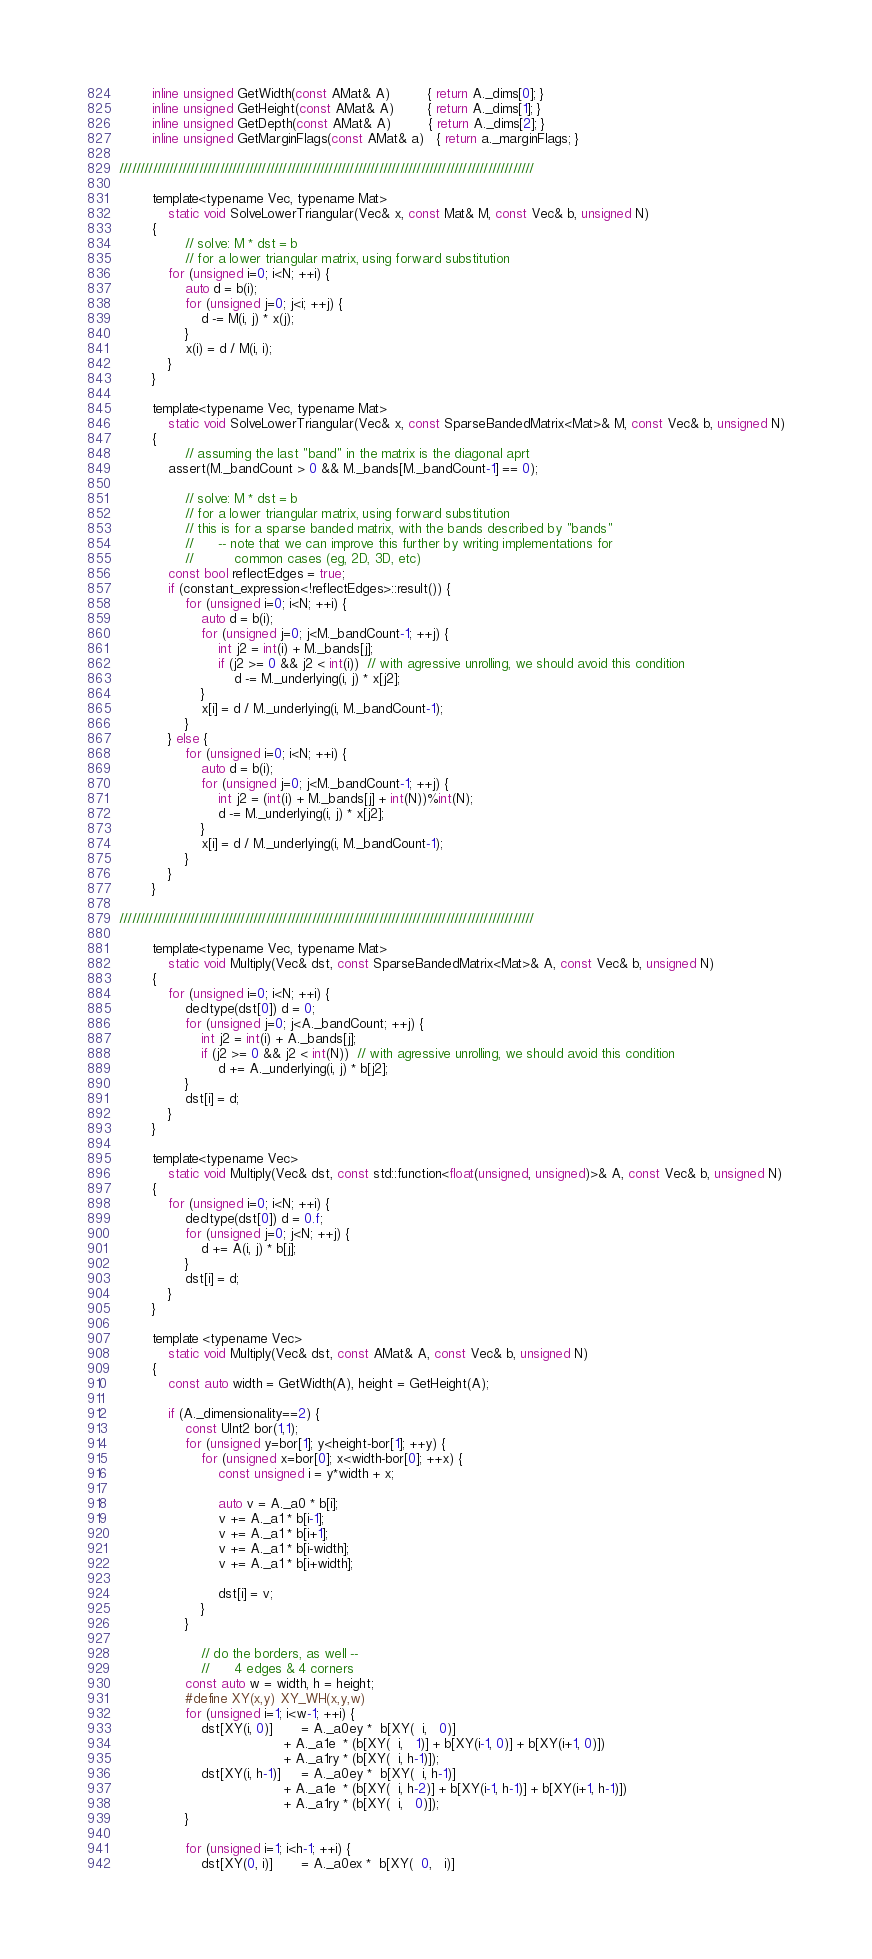<code> <loc_0><loc_0><loc_500><loc_500><_C_>        inline unsigned GetWidth(const AMat& A)         { return A._dims[0]; }
        inline unsigned GetHeight(const AMat& A)        { return A._dims[1]; }
        inline unsigned GetDepth(const AMat& A)         { return A._dims[2]; }
        inline unsigned GetMarginFlags(const AMat& a)   { return a._marginFlags; }

///////////////////////////////////////////////////////////////////////////////////////////////////

        template<typename Vec, typename Mat>
            static void SolveLowerTriangular(Vec& x, const Mat& M, const Vec& b, unsigned N)
        {
                // solve: M * dst = b
                // for a lower triangular matrix, using forward substitution
            for (unsigned i=0; i<N; ++i) {
                auto d = b(i);
                for (unsigned j=0; j<i; ++j) {
                    d -= M(i, j) * x(j);
                }
                x(i) = d / M(i, i);
            }
        }

        template<typename Vec, typename Mat>
            static void SolveLowerTriangular(Vec& x, const SparseBandedMatrix<Mat>& M, const Vec& b, unsigned N)
        {
                // assuming the last "band" in the matrix is the diagonal aprt
            assert(M._bandCount > 0 && M._bands[M._bandCount-1] == 0);

                // solve: M * dst = b
                // for a lower triangular matrix, using forward substitution
                // this is for a sparse banded matrix, with the bands described by "bands"
                //      -- note that we can improve this further by writing implementations for
                //          common cases (eg, 2D, 3D, etc)
            const bool reflectEdges = true;
            if (constant_expression<!reflectEdges>::result()) {
                for (unsigned i=0; i<N; ++i) {
                    auto d = b(i);
                    for (unsigned j=0; j<M._bandCount-1; ++j) {
                        int j2 = int(i) + M._bands[j];
                        if (j2 >= 0 && j2 < int(i))  // with agressive unrolling, we should avoid this condition
                            d -= M._underlying(i, j) * x[j2];
                    }
                    x[i] = d / M._underlying(i, M._bandCount-1);
                }
            } else {
                for (unsigned i=0; i<N; ++i) {
                    auto d = b(i);
                    for (unsigned j=0; j<M._bandCount-1; ++j) {
                        int j2 = (int(i) + M._bands[j] + int(N))%int(N);
                        d -= M._underlying(i, j) * x[j2];
                    }
                    x[i] = d / M._underlying(i, M._bandCount-1);
                }
            }
        }

///////////////////////////////////////////////////////////////////////////////////////////////////

        template<typename Vec, typename Mat>
            static void Multiply(Vec& dst, const SparseBandedMatrix<Mat>& A, const Vec& b, unsigned N)
        {
            for (unsigned i=0; i<N; ++i) {
                decltype(dst[0]) d = 0;
                for (unsigned j=0; j<A._bandCount; ++j) {
                    int j2 = int(i) + A._bands[j];
                    if (j2 >= 0 && j2 < int(N))  // with agressive unrolling, we should avoid this condition
                        d += A._underlying(i, j) * b[j2];
                }
                dst[i] = d;
            }
        }

        template<typename Vec>
            static void Multiply(Vec& dst, const std::function<float(unsigned, unsigned)>& A, const Vec& b, unsigned N)
        {
            for (unsigned i=0; i<N; ++i) {
                decltype(dst[0]) d = 0.f;
                for (unsigned j=0; j<N; ++j) {
                    d += A(i, j) * b[j];
                }
                dst[i] = d;
            }
        }

        template <typename Vec>
            static void Multiply(Vec& dst, const AMat& A, const Vec& b, unsigned N)
        {
            const auto width = GetWidth(A), height = GetHeight(A);

            if (A._dimensionality==2) {
                const UInt2 bor(1,1);
                for (unsigned y=bor[1]; y<height-bor[1]; ++y) {
                    for (unsigned x=bor[0]; x<width-bor[0]; ++x) {
                        const unsigned i = y*width + x;

                        auto v = A._a0 * b[i];
                        v += A._a1 * b[i-1];
                        v += A._a1 * b[i+1];
                        v += A._a1 * b[i-width];
                        v += A._a1 * b[i+width];

                        dst[i] = v;
                    }
                }

                    // do the borders, as well --
                    //      4 edges & 4 corners
                const auto w = width, h = height;
                #define XY(x,y) XY_WH(x,y,w)
                for (unsigned i=1; i<w-1; ++i) {
                    dst[XY(i, 0)]       = A._a0ey *  b[XY(  i,   0)] 
                                        + A._a1e  * (b[XY(  i,   1)] + b[XY(i-1, 0)] + b[XY(i+1, 0)])
                                        + A._a1ry * (b[XY(  i, h-1)]);
                    dst[XY(i, h-1)]     = A._a0ey *  b[XY(  i, h-1)] 
                                        + A._a1e  * (b[XY(  i, h-2)] + b[XY(i-1, h-1)] + b[XY(i+1, h-1)])
                                        + A._a1ry * (b[XY(  i,   0)]);
                }

                for (unsigned i=1; i<h-1; ++i) {
                    dst[XY(0, i)]       = A._a0ex *  b[XY(  0,   i)] </code> 